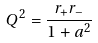<formula> <loc_0><loc_0><loc_500><loc_500>Q ^ { 2 } = \frac { r _ { + } r _ { - } } { 1 + a ^ { 2 } }</formula> 